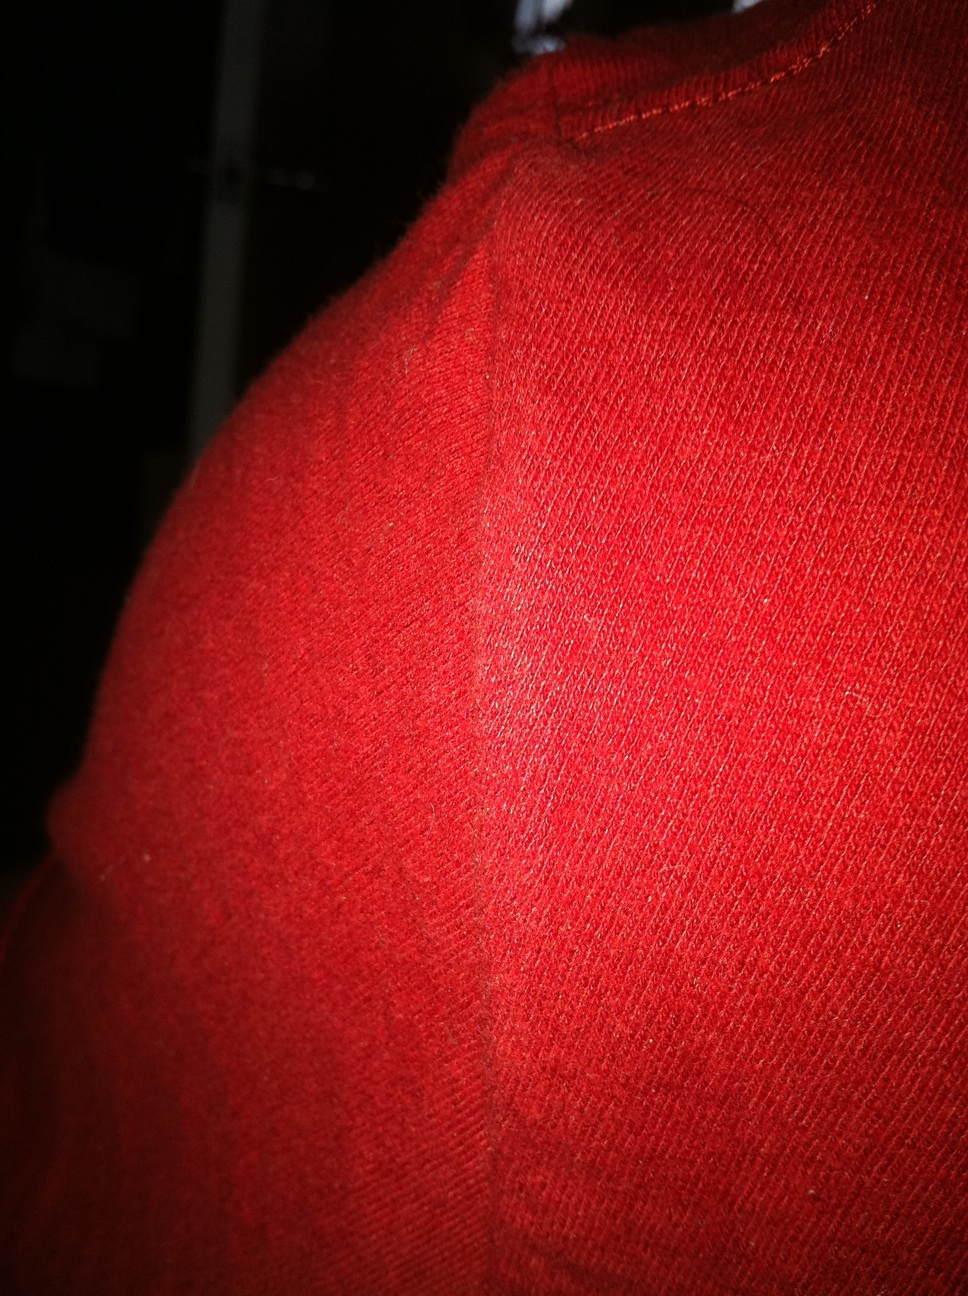What color is it? The item prominently depicted in the image has a vibrant red color, which is vibrant and distinctly noticeable. 